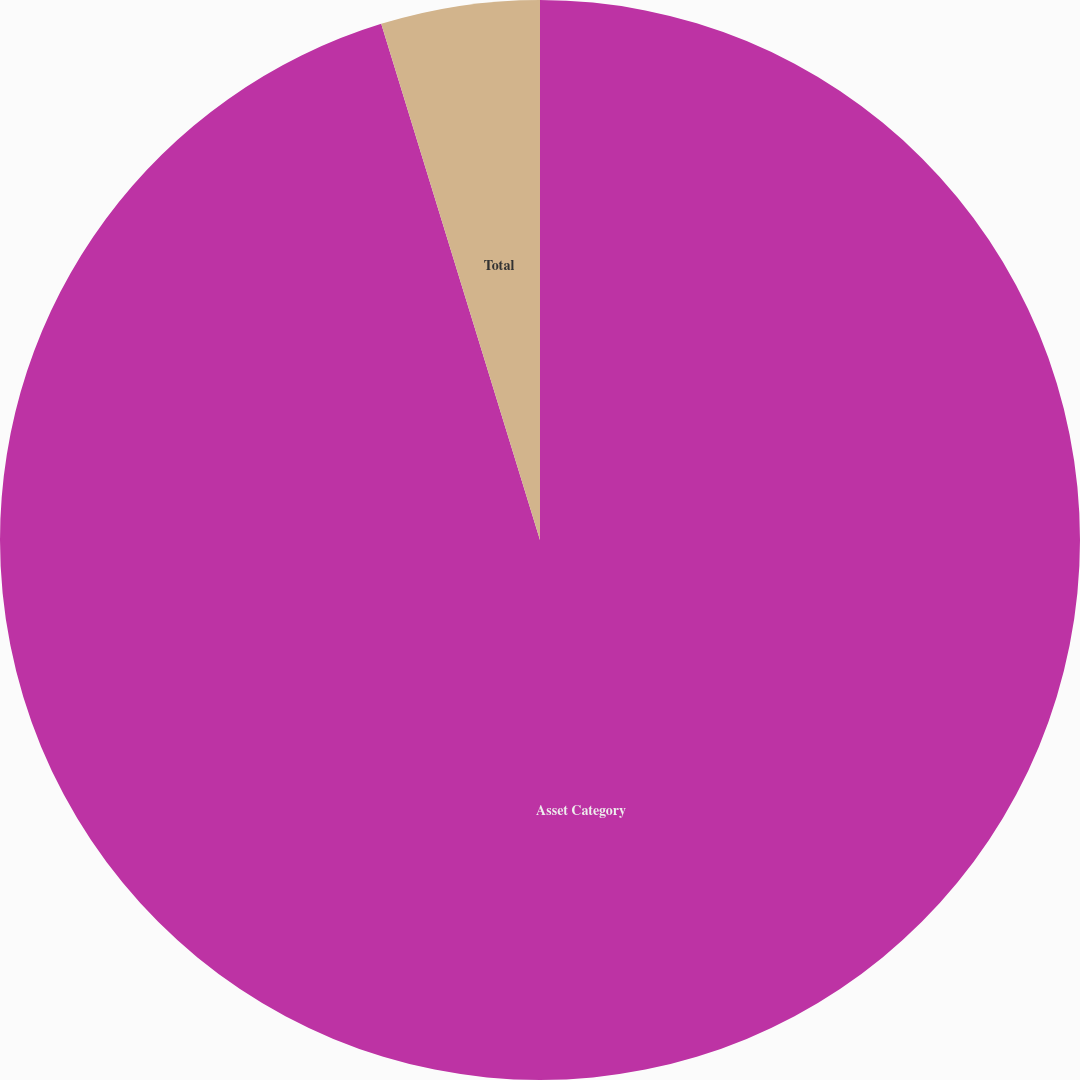Convert chart to OTSL. <chart><loc_0><loc_0><loc_500><loc_500><pie_chart><fcel>Asset Category<fcel>Total<nl><fcel>95.25%<fcel>4.75%<nl></chart> 